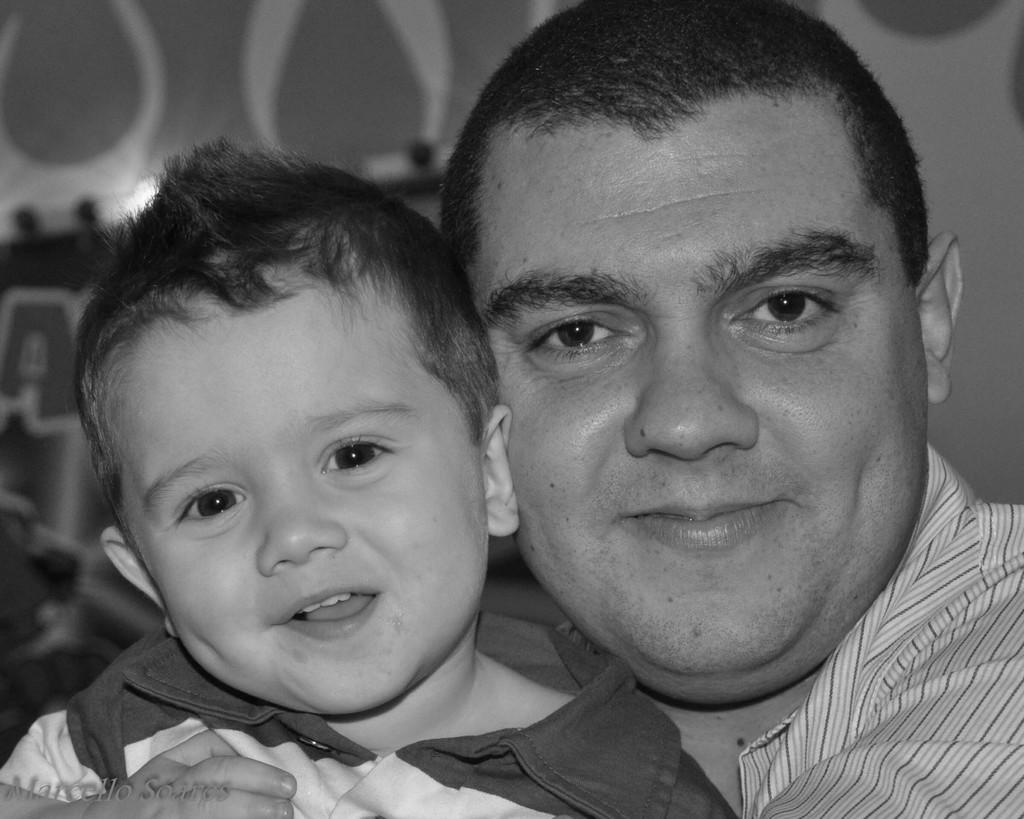Who is present in the image? There is a person and a kid in the image. What is the person wearing? The person is wearing a checked shirt. What is the kid wearing? The kid is wearing a white and black dress. What can be seen in the background of the image? There is a wall in the background of the image. Can you see a hen walking by the river in the image? There is no hen or river present in the image. 